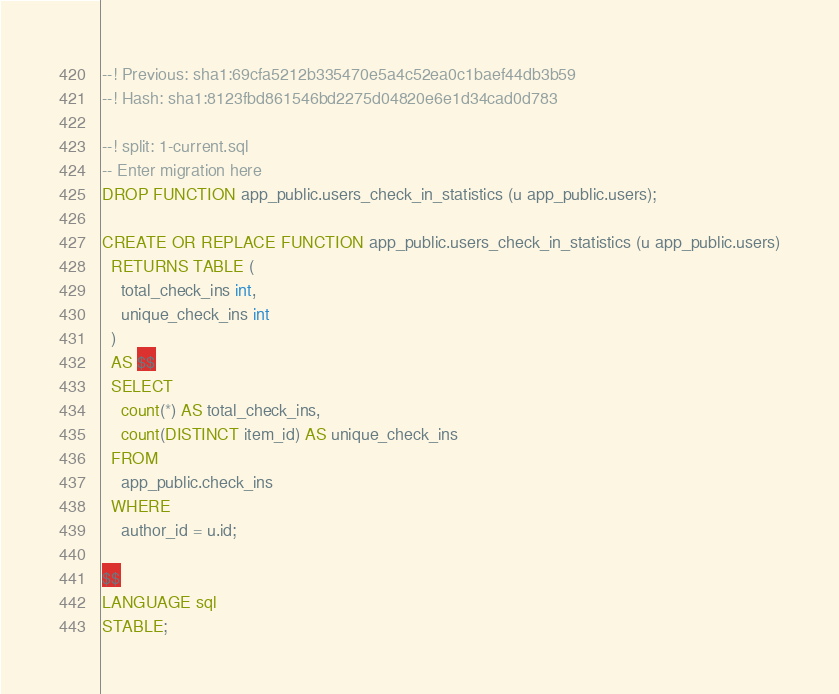Convert code to text. <code><loc_0><loc_0><loc_500><loc_500><_SQL_>--! Previous: sha1:69cfa5212b335470e5a4c52ea0c1baef44db3b59
--! Hash: sha1:8123fbd861546bd2275d04820e6e1d34cad0d783

--! split: 1-current.sql
-- Enter migration here
DROP FUNCTION app_public.users_check_in_statistics (u app_public.users);

CREATE OR REPLACE FUNCTION app_public.users_check_in_statistics (u app_public.users)
  RETURNS TABLE (
    total_check_ins int,
    unique_check_ins int
  )
  AS $$
  SELECT
    count(*) AS total_check_ins,
    count(DISTINCT item_id) AS unique_check_ins
  FROM
    app_public.check_ins
  WHERE
    author_id = u.id;

$$
LANGUAGE sql
STABLE;
</code> 